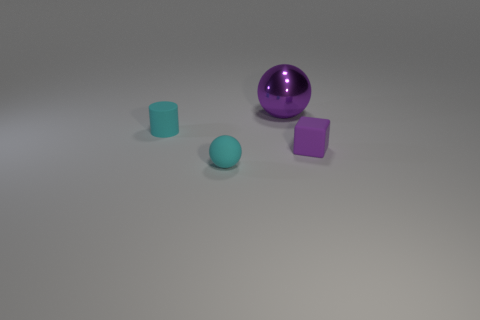Are there any metal things of the same size as the rubber ball?
Offer a very short reply. No. What is the material of the purple thing that is the same size as the matte cylinder?
Your response must be concise. Rubber. What shape is the tiny cyan object in front of the rubber cylinder?
Give a very brief answer. Sphere. Is the purple object right of the purple metal thing made of the same material as the cyan object that is in front of the cyan rubber cylinder?
Your response must be concise. Yes. What number of cyan rubber things are the same shape as the large metallic thing?
Provide a succinct answer. 1. What material is the ball that is the same color as the small matte cube?
Keep it short and to the point. Metal. How many objects are either large purple metallic balls or tiny matte things that are right of the large shiny thing?
Your response must be concise. 2. What material is the tiny block?
Provide a short and direct response. Rubber. What is the material of the small cyan object that is the same shape as the big purple thing?
Ensure brevity in your answer.  Rubber. What is the color of the tiny matte object that is on the left side of the sphere that is in front of the small cube?
Provide a succinct answer. Cyan. 